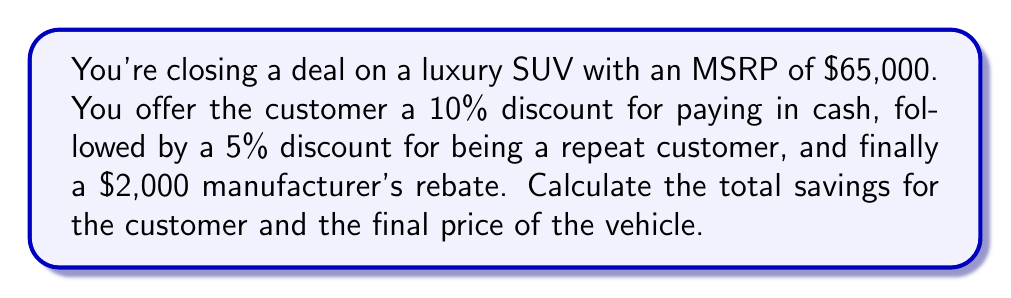Give your solution to this math problem. Let's break this down step-by-step:

1) First, let's apply the 10% cash discount:
   $$65,000 \times 0.10 = $6,500$$
   New price after first discount: $$65,000 - 6,500 = $58,500$$

2) Now, we apply the 5% repeat customer discount to the new price:
   $$58,500 \times 0.05 = $2,925$$
   New price after second discount: $$58,500 - 2,925 = $55,575$$

3) Finally, we subtract the $2,000 manufacturer's rebate:
   $$55,575 - 2,000 = $53,575$$

4) To calculate the total savings, we subtract the final price from the original MSRP:
   $$65,000 - 53,575 = $11,425$$

Therefore, the total savings for the customer is $11,425, and the final price of the vehicle is $53,575.
Answer: Total savings: $11,425
Final price: $53,575 